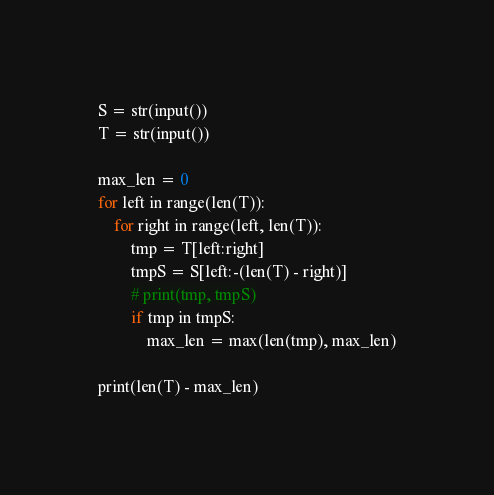Convert code to text. <code><loc_0><loc_0><loc_500><loc_500><_Python_>S = str(input())
T = str(input())

max_len = 0
for left in range(len(T)):
    for right in range(left, len(T)):
        tmp = T[left:right]
        tmpS = S[left:-(len(T) - right)]
        # print(tmp, tmpS)
        if tmp in tmpS:
            max_len = max(len(tmp), max_len)

print(len(T) - max_len)</code> 